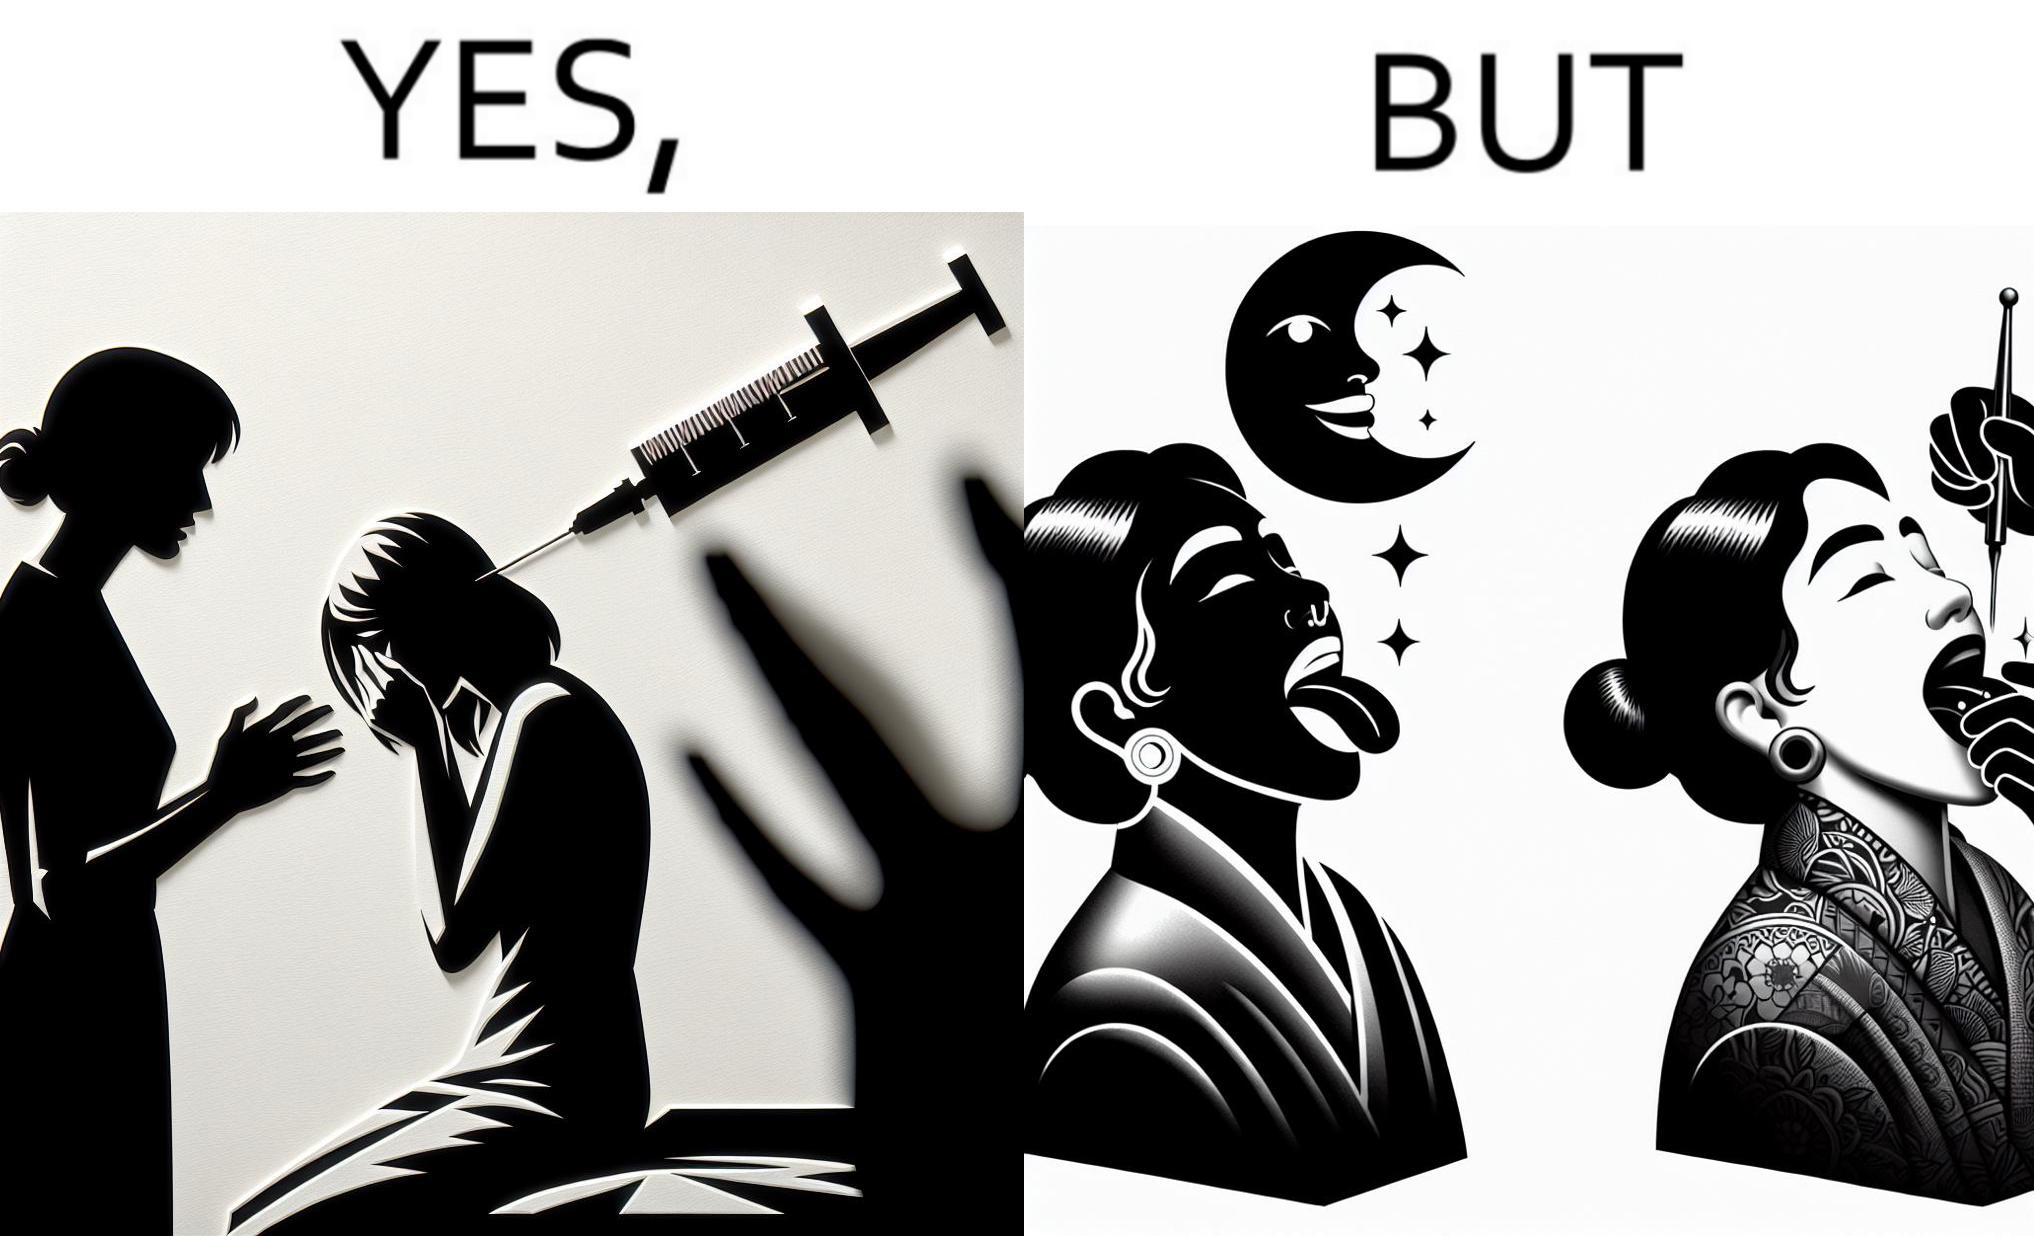Is this a satirical image? Yes, this image is satirical. 